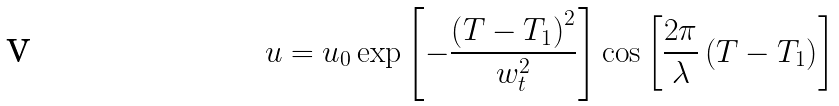Convert formula to latex. <formula><loc_0><loc_0><loc_500><loc_500>u = u _ { 0 } \exp \left [ - \frac { \left ( T - T _ { 1 } \right ) ^ { 2 } } { w _ { t } ^ { 2 } } \right ] \cos \left [ \frac { 2 \pi } \lambda \left ( T - T _ { 1 } \right ) \right ]</formula> 